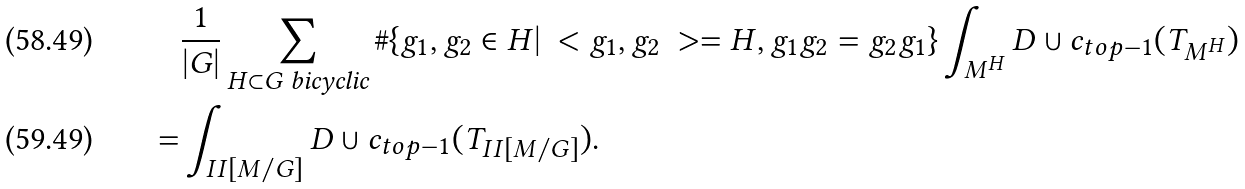Convert formula to latex. <formula><loc_0><loc_0><loc_500><loc_500>& \frac { 1 } { | G | } \sum _ { H \subset G \text { bicyclic} } \# \{ g _ { 1 } , g _ { 2 } \in H | \ < g _ { 1 } , g _ { 2 } \ > = H , g _ { 1 } g _ { 2 } = g _ { 2 } g _ { 1 } \} \int _ { M ^ { H } } D \cup c _ { t o p - 1 } ( T _ { M ^ { H } } ) \\ = & \int _ { I I [ M / G ] } D \cup c _ { t o p - 1 } ( T _ { I I [ M / G ] } ) .</formula> 